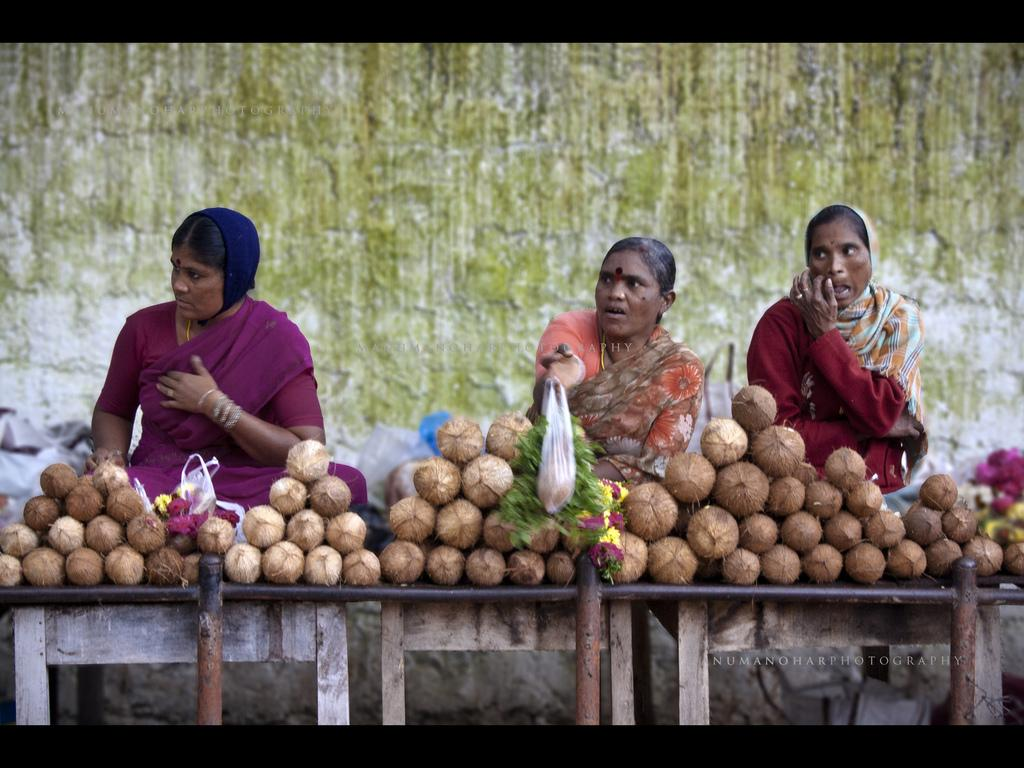What is the main subject of the image? The main subject of the image is coconut stalls. How many women are sitting in the image? There are three women sitting in the image. Is there a beggar asking for attention from the women in the image? There is no mention of a beggar or anyone asking for attention in the image. 